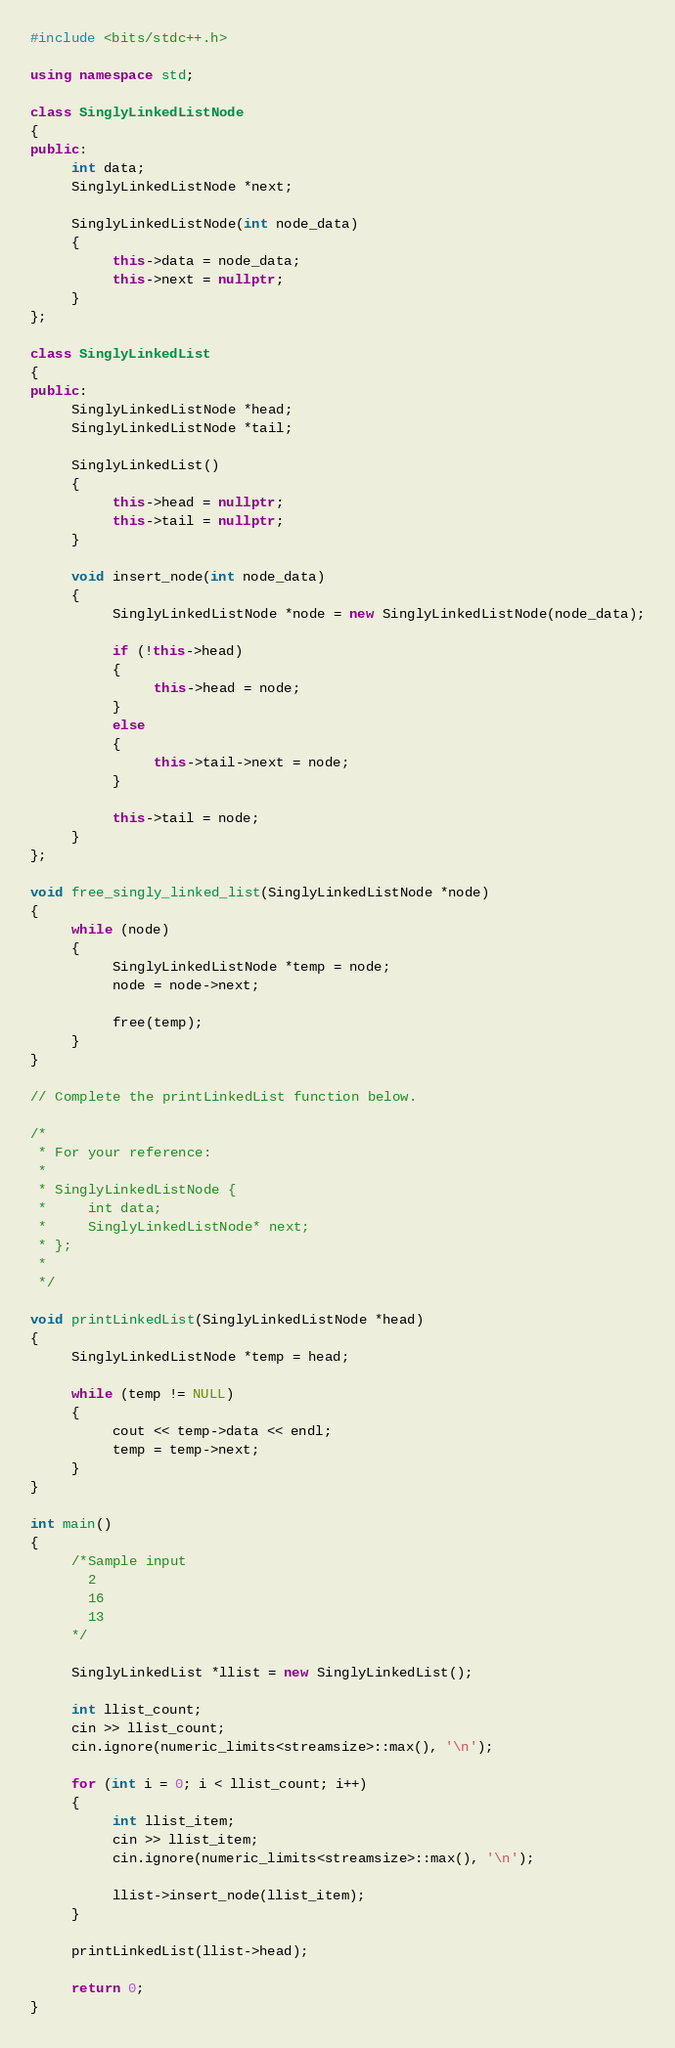<code> <loc_0><loc_0><loc_500><loc_500><_C++_>#include <bits/stdc++.h>

using namespace std;

class SinglyLinkedListNode
{
public:
     int data;
     SinglyLinkedListNode *next;

     SinglyLinkedListNode(int node_data)
     {
          this->data = node_data;
          this->next = nullptr;
     }
};

class SinglyLinkedList
{
public:
     SinglyLinkedListNode *head;
     SinglyLinkedListNode *tail;

     SinglyLinkedList()
     {
          this->head = nullptr;
          this->tail = nullptr;
     }

     void insert_node(int node_data)
     {
          SinglyLinkedListNode *node = new SinglyLinkedListNode(node_data);

          if (!this->head)
          {
               this->head = node;
          }
          else
          {
               this->tail->next = node;
          }

          this->tail = node;
     }
};

void free_singly_linked_list(SinglyLinkedListNode *node)
{
     while (node)
     {
          SinglyLinkedListNode *temp = node;
          node = node->next;

          free(temp);
     }
}

// Complete the printLinkedList function below.

/*
 * For your reference:
 *
 * SinglyLinkedListNode {
 *     int data;
 *     SinglyLinkedListNode* next;
 * };
 *
 */

void printLinkedList(SinglyLinkedListNode *head)
{
     SinglyLinkedListNode *temp = head;

     while (temp != NULL)
     {
          cout << temp->data << endl;
          temp = temp->next;
     }
}

int main()
{
     /*Sample input
       2
       16
       13
     */

     SinglyLinkedList *llist = new SinglyLinkedList();

     int llist_count;
     cin >> llist_count;
     cin.ignore(numeric_limits<streamsize>::max(), '\n');

     for (int i = 0; i < llist_count; i++)
     {
          int llist_item;
          cin >> llist_item;
          cin.ignore(numeric_limits<streamsize>::max(), '\n');

          llist->insert_node(llist_item);
     }

     printLinkedList(llist->head);

     return 0;
}
</code> 